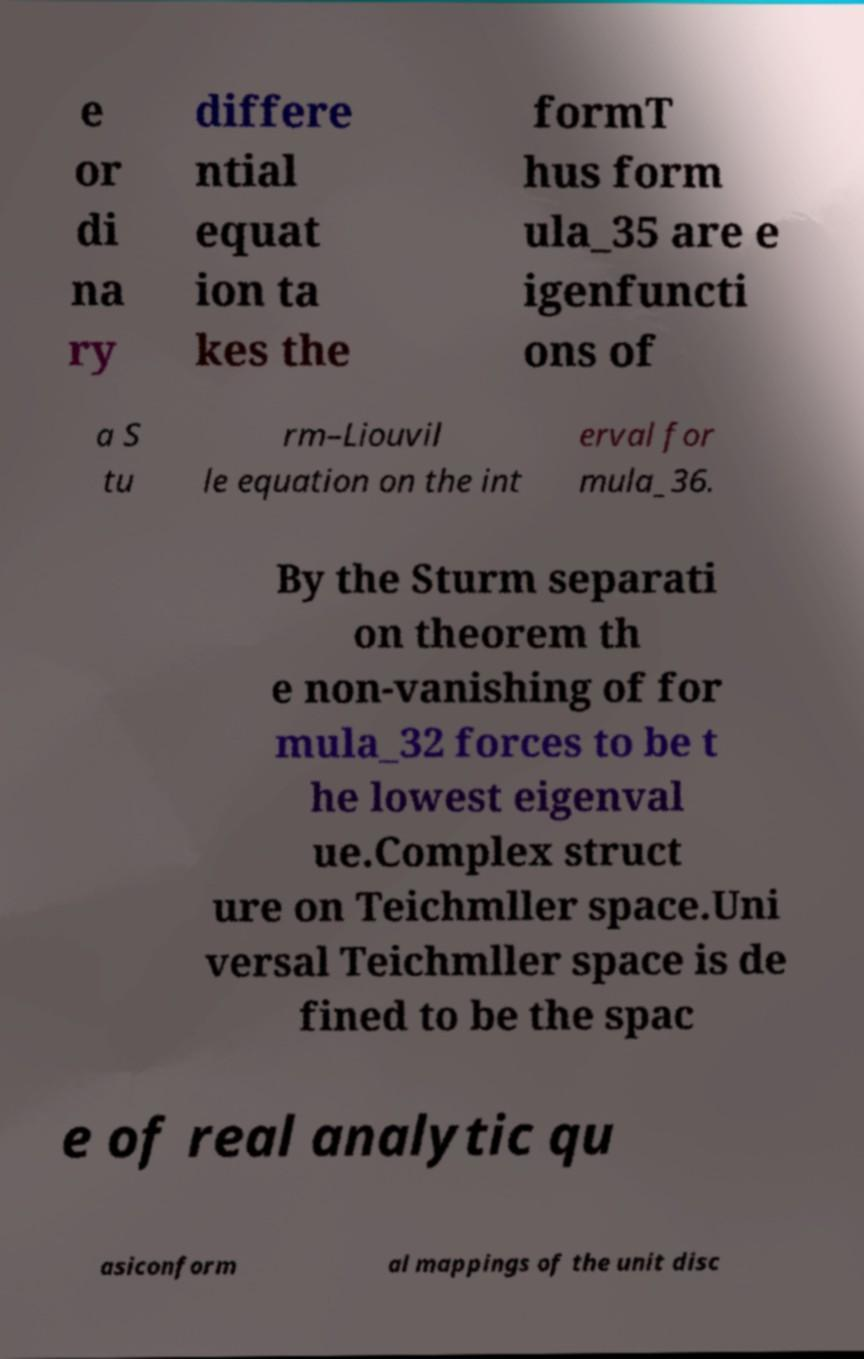Could you extract and type out the text from this image? e or di na ry differe ntial equat ion ta kes the formT hus form ula_35 are e igenfuncti ons of a S tu rm–Liouvil le equation on the int erval for mula_36. By the Sturm separati on theorem th e non-vanishing of for mula_32 forces to be t he lowest eigenval ue.Complex struct ure on Teichmller space.Uni versal Teichmller space is de fined to be the spac e of real analytic qu asiconform al mappings of the unit disc 